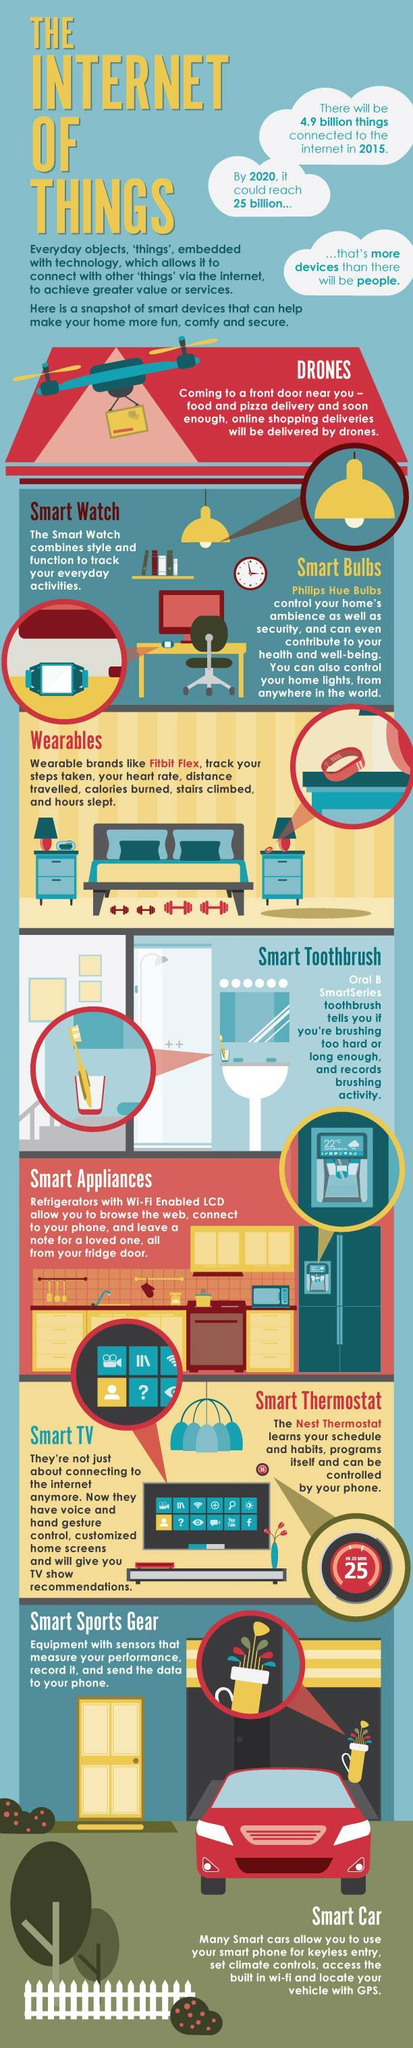What is the color of the toothbrush-orange, yellow, red?
Answer the question with a short phrase. yellow What is the color of the car-blue, red or orange? red 